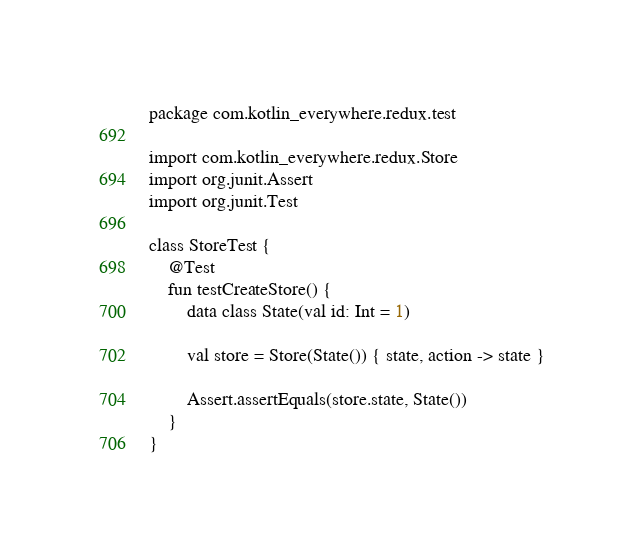Convert code to text. <code><loc_0><loc_0><loc_500><loc_500><_Kotlin_>package com.kotlin_everywhere.redux.test

import com.kotlin_everywhere.redux.Store
import org.junit.Assert
import org.junit.Test

class StoreTest {
    @Test
    fun testCreateStore() {
        data class State(val id: Int = 1)

        val store = Store(State()) { state, action -> state }

        Assert.assertEquals(store.state, State())
    }
}</code> 